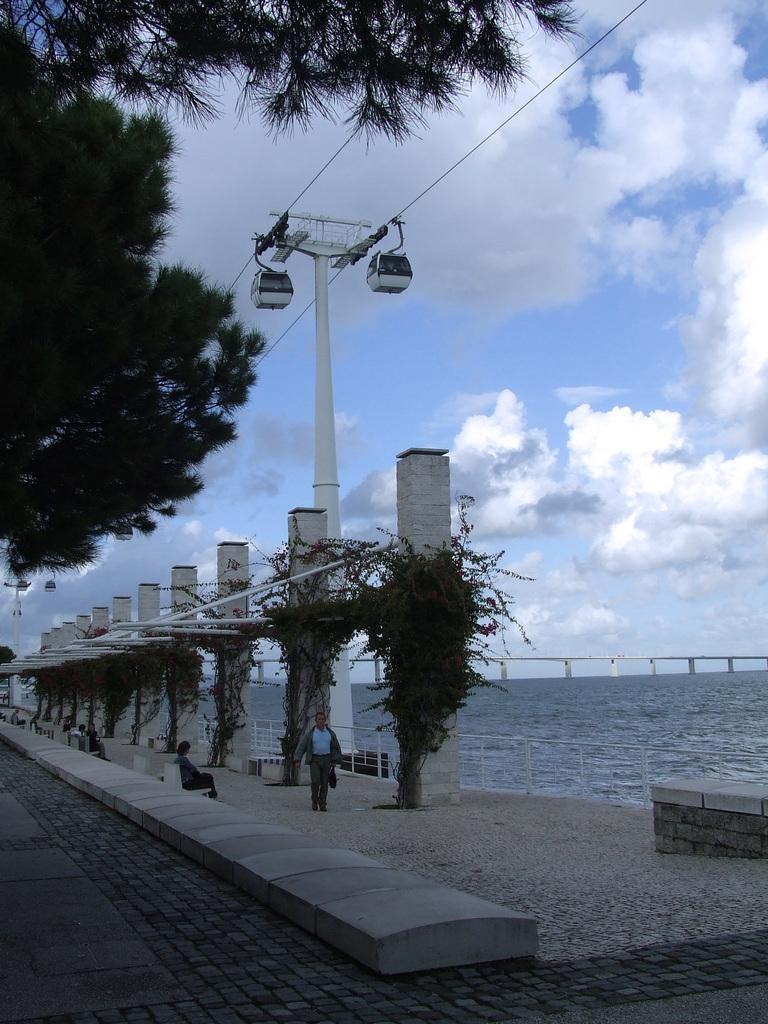In one or two sentences, can you explain what this image depicts? In this image we can see few trees and we can see creepers on the pillars and there are few people sitting on the benches and there is a person walking. We can see the water and there is a bridge over the water and we can see few cable cars. At the top we can see the sky with clouds. 